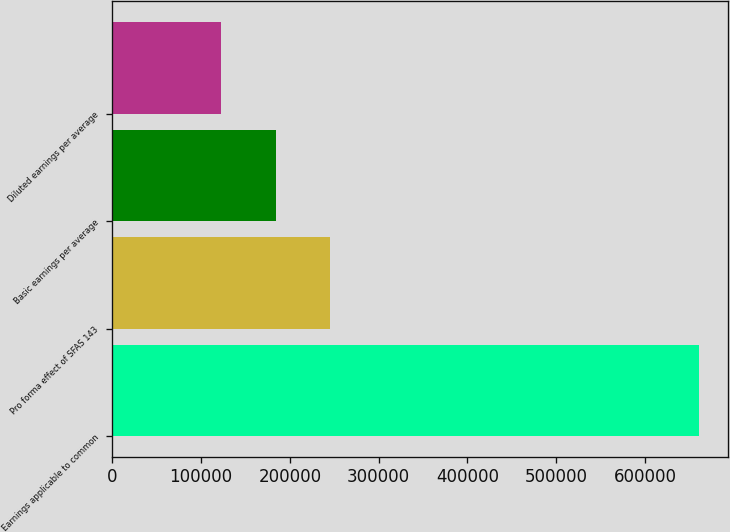Convert chart to OTSL. <chart><loc_0><loc_0><loc_500><loc_500><bar_chart><fcel>Earnings applicable to common<fcel>Pro forma effect of SFAS 143<fcel>Basic earnings per average<fcel>Diluted earnings per average<nl><fcel>660708<fcel>245393<fcel>184046<fcel>122698<nl></chart> 